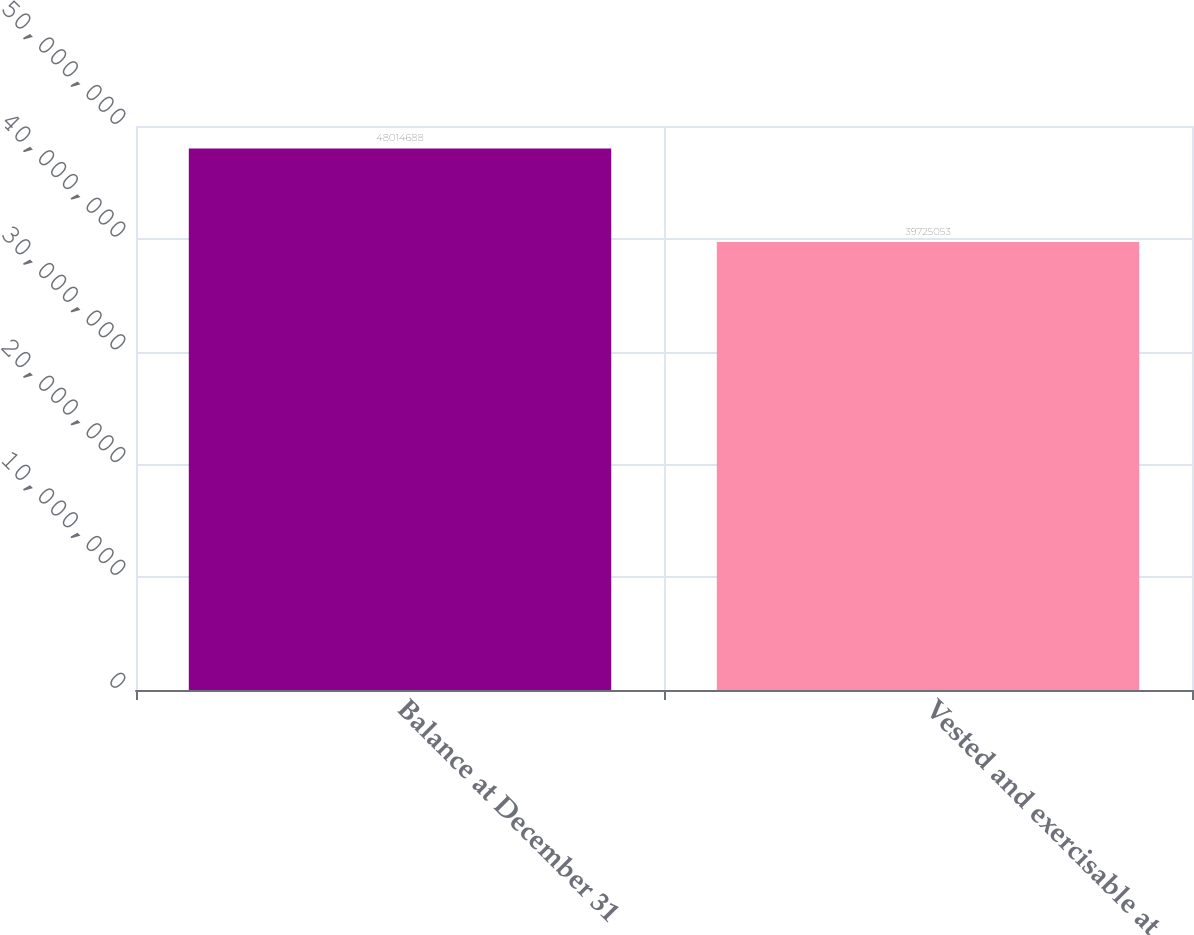Convert chart to OTSL. <chart><loc_0><loc_0><loc_500><loc_500><bar_chart><fcel>Balance at December 31<fcel>Vested and exercisable at<nl><fcel>4.80147e+07<fcel>3.97251e+07<nl></chart> 